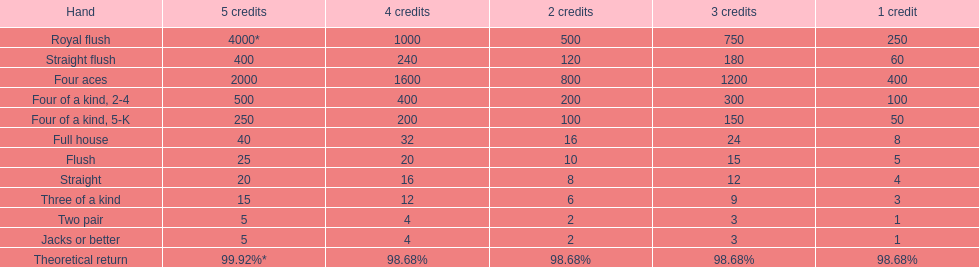What could be the highest earning for an individual possessing a full house? 40. 